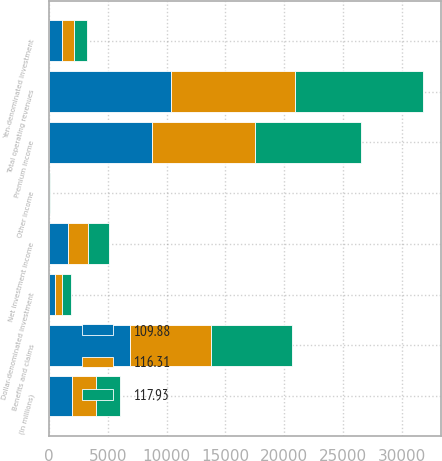<chart> <loc_0><loc_0><loc_500><loc_500><stacked_bar_chart><ecel><fcel>(In millions)<fcel>Premium income<fcel>Yen-denominated investment<fcel>Dollar-denominated investment<fcel>Net investment income<fcel>Other income<fcel>Total operating revenues<fcel>Benefits and claims<nl><fcel>117.93<fcel>2007<fcel>9037<fcel>1102<fcel>699<fcel>1801<fcel>27<fcel>10865<fcel>6935<nl><fcel>116.31<fcel>2006<fcel>8762<fcel>1064<fcel>624<fcel>1688<fcel>25<fcel>10475<fcel>6847<nl><fcel>109.88<fcel>2005<fcel>8745<fcel>1111<fcel>524<fcel>1635<fcel>31<fcel>10411<fcel>6898<nl></chart> 